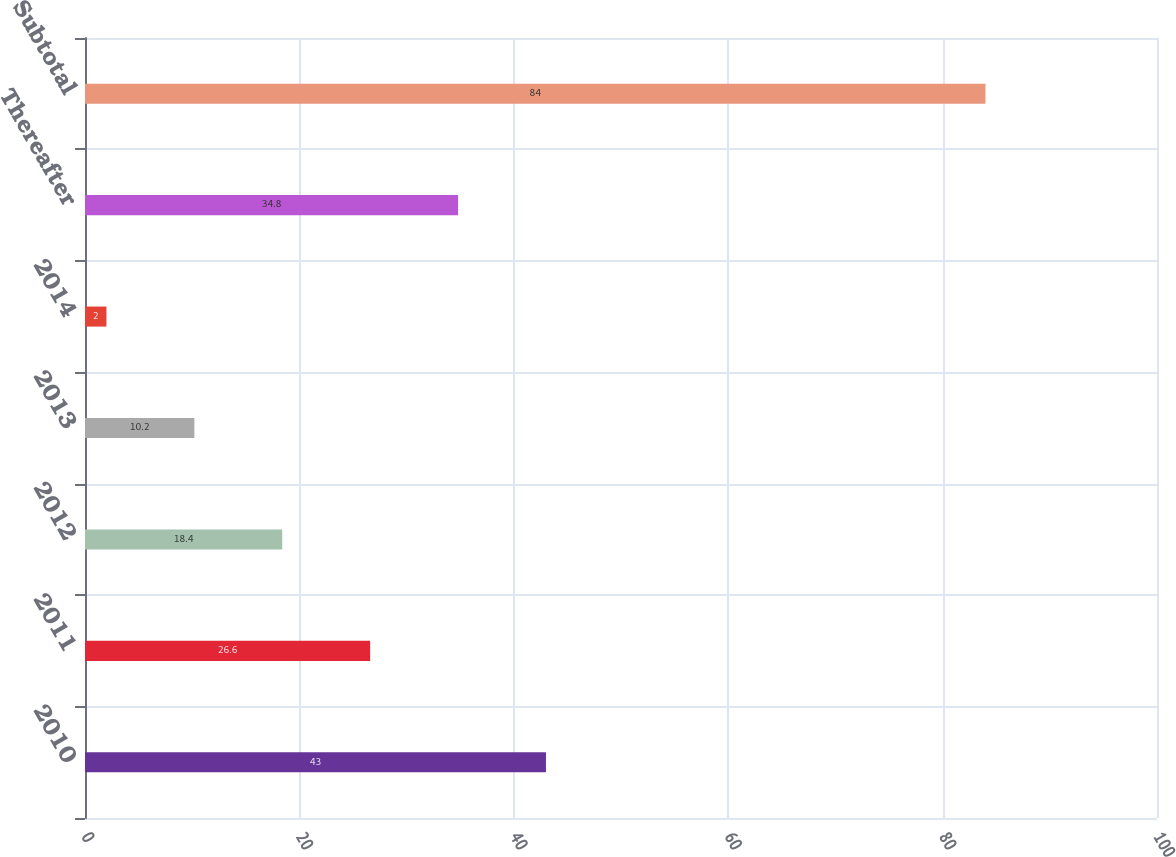Convert chart. <chart><loc_0><loc_0><loc_500><loc_500><bar_chart><fcel>2010<fcel>2011<fcel>2012<fcel>2013<fcel>2014<fcel>Thereafter<fcel>Subtotal<nl><fcel>43<fcel>26.6<fcel>18.4<fcel>10.2<fcel>2<fcel>34.8<fcel>84<nl></chart> 